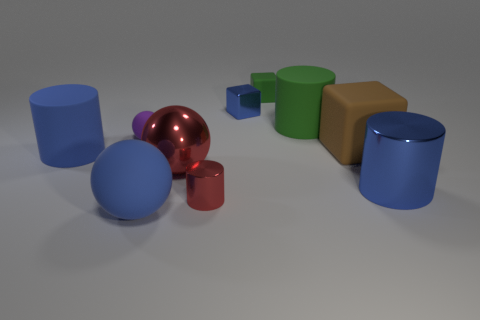There is another rubber cylinder that is the same size as the green cylinder; what color is it?
Offer a terse response. Blue. Is there another rubber thing that has the same shape as the small red thing?
Offer a very short reply. Yes. There is a cylinder in front of the large cylinder in front of the large rubber cylinder that is left of the small purple rubber object; what is it made of?
Provide a short and direct response. Metal. How many other things are there of the same size as the purple object?
Give a very brief answer. 3. The big matte ball is what color?
Make the answer very short. Blue. How many metallic objects are big balls or blue things?
Keep it short and to the point. 3. Are there any other things that are made of the same material as the red ball?
Keep it short and to the point. Yes. What size is the cylinder to the right of the rubber cylinder behind the cylinder that is left of the tiny red shiny thing?
Provide a short and direct response. Large. What size is the metal thing that is in front of the big blue matte cylinder and behind the big shiny cylinder?
Offer a very short reply. Large. Do the large rubber cylinder on the left side of the tiny rubber ball and the rubber cylinder that is behind the brown cube have the same color?
Offer a very short reply. No. 